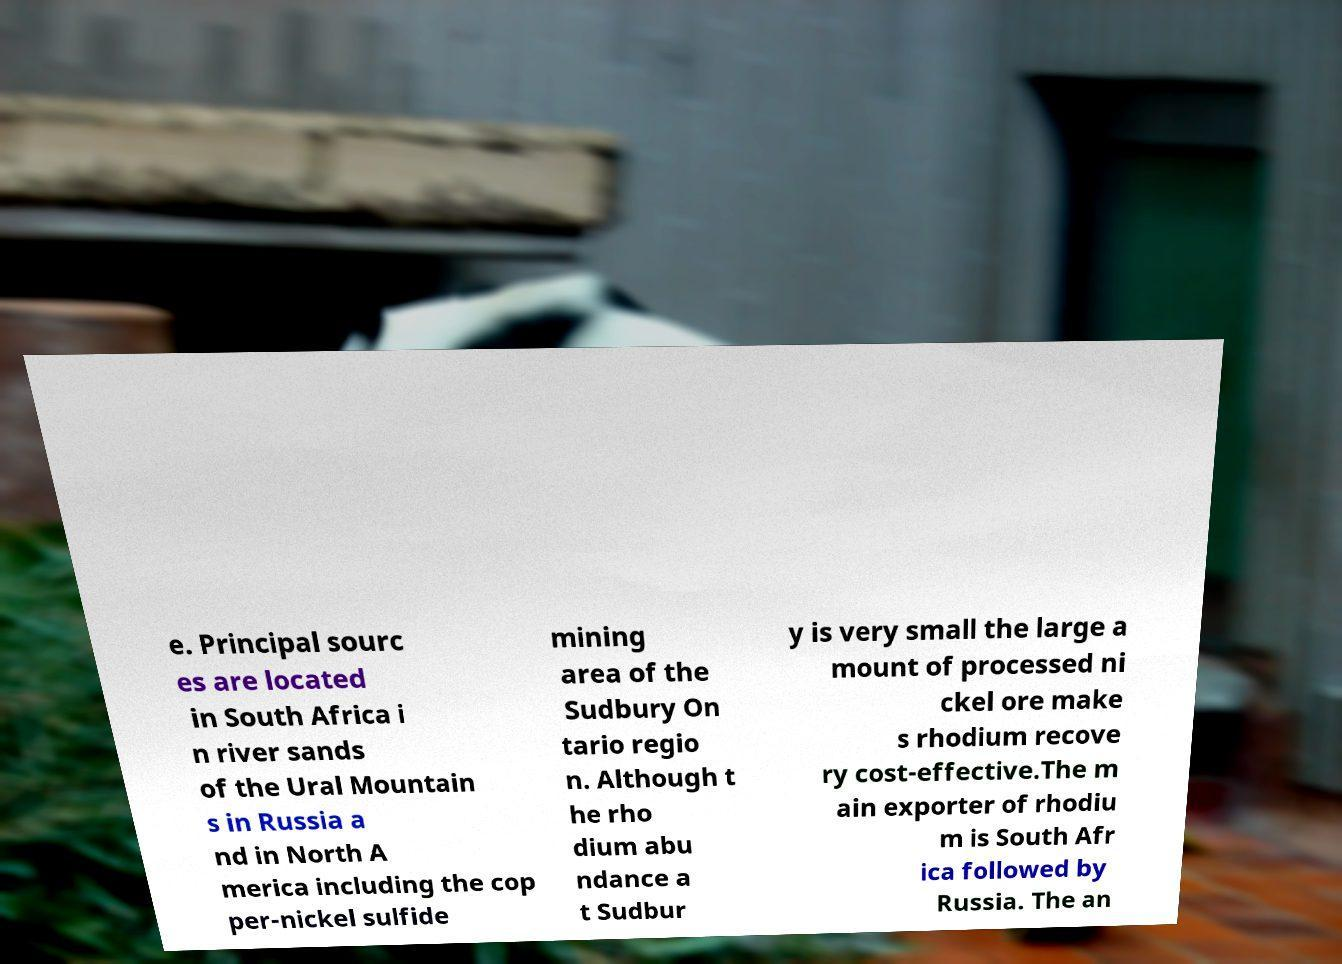For documentation purposes, I need the text within this image transcribed. Could you provide that? e. Principal sourc es are located in South Africa i n river sands of the Ural Mountain s in Russia a nd in North A merica including the cop per-nickel sulfide mining area of the Sudbury On tario regio n. Although t he rho dium abu ndance a t Sudbur y is very small the large a mount of processed ni ckel ore make s rhodium recove ry cost-effective.The m ain exporter of rhodiu m is South Afr ica followed by Russia. The an 